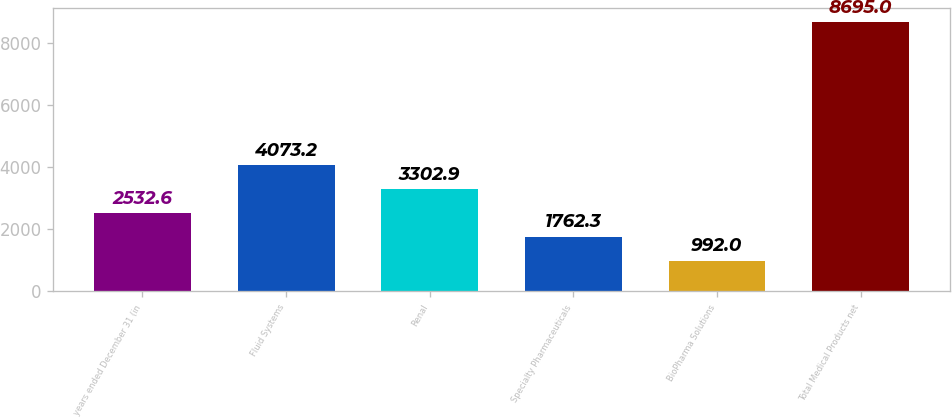Convert chart. <chart><loc_0><loc_0><loc_500><loc_500><bar_chart><fcel>years ended December 31 (in<fcel>Fluid Systems<fcel>Renal<fcel>Specialty Pharmaceuticals<fcel>BioPharma Solutions<fcel>Total Medical Products net<nl><fcel>2532.6<fcel>4073.2<fcel>3302.9<fcel>1762.3<fcel>992<fcel>8695<nl></chart> 